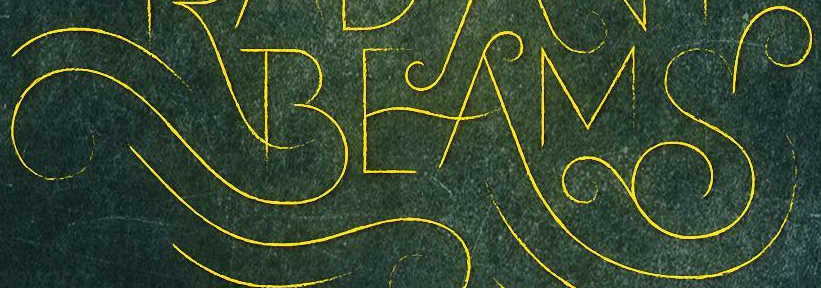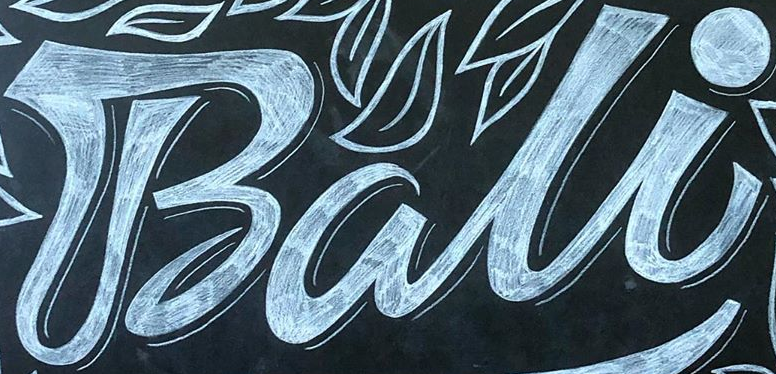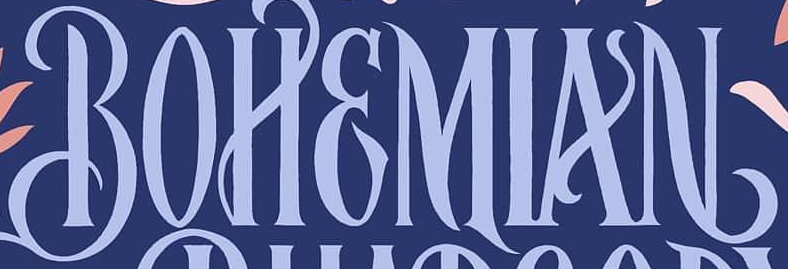What words can you see in these images in sequence, separated by a semicolon? BEAMS; Bali; BOHEMIAN 